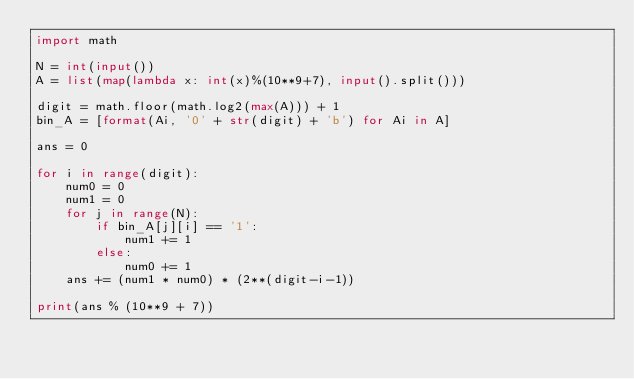Convert code to text. <code><loc_0><loc_0><loc_500><loc_500><_Python_>import math

N = int(input())
A = list(map(lambda x: int(x)%(10**9+7), input().split()))

digit = math.floor(math.log2(max(A))) + 1
bin_A = [format(Ai, '0' + str(digit) + 'b') for Ai in A]

ans = 0

for i in range(digit):
    num0 = 0
    num1 = 0
    for j in range(N):
        if bin_A[j][i] == '1':
            num1 += 1
        else:
            num0 += 1
    ans += (num1 * num0) * (2**(digit-i-1))

print(ans % (10**9 + 7))</code> 